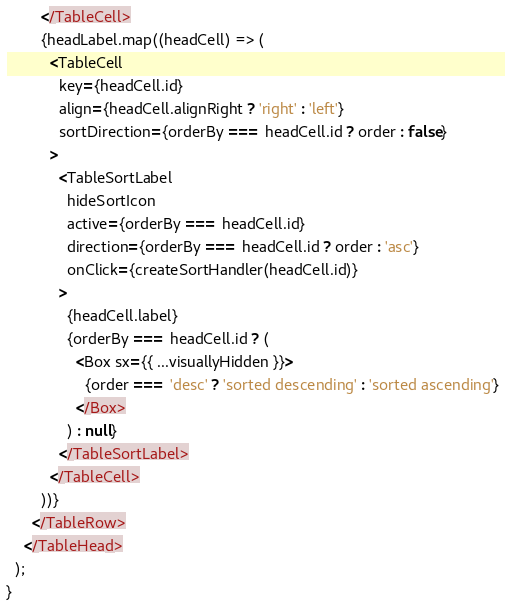Convert code to text. <code><loc_0><loc_0><loc_500><loc_500><_JavaScript_>
        </TableCell>
        {headLabel.map((headCell) => (
          <TableCell
            key={headCell.id}
            align={headCell.alignRight ? 'right' : 'left'}
            sortDirection={orderBy === headCell.id ? order : false}
          >
            <TableSortLabel
              hideSortIcon
              active={orderBy === headCell.id}
              direction={orderBy === headCell.id ? order : 'asc'}
              onClick={createSortHandler(headCell.id)}
            >
              {headCell.label}
              {orderBy === headCell.id ? (
                <Box sx={{ ...visuallyHidden }}>
                  {order === 'desc' ? 'sorted descending' : 'sorted ascending'}
                </Box>
              ) : null}
            </TableSortLabel>
          </TableCell>
        ))}
      </TableRow>
    </TableHead>
  );
}
</code> 